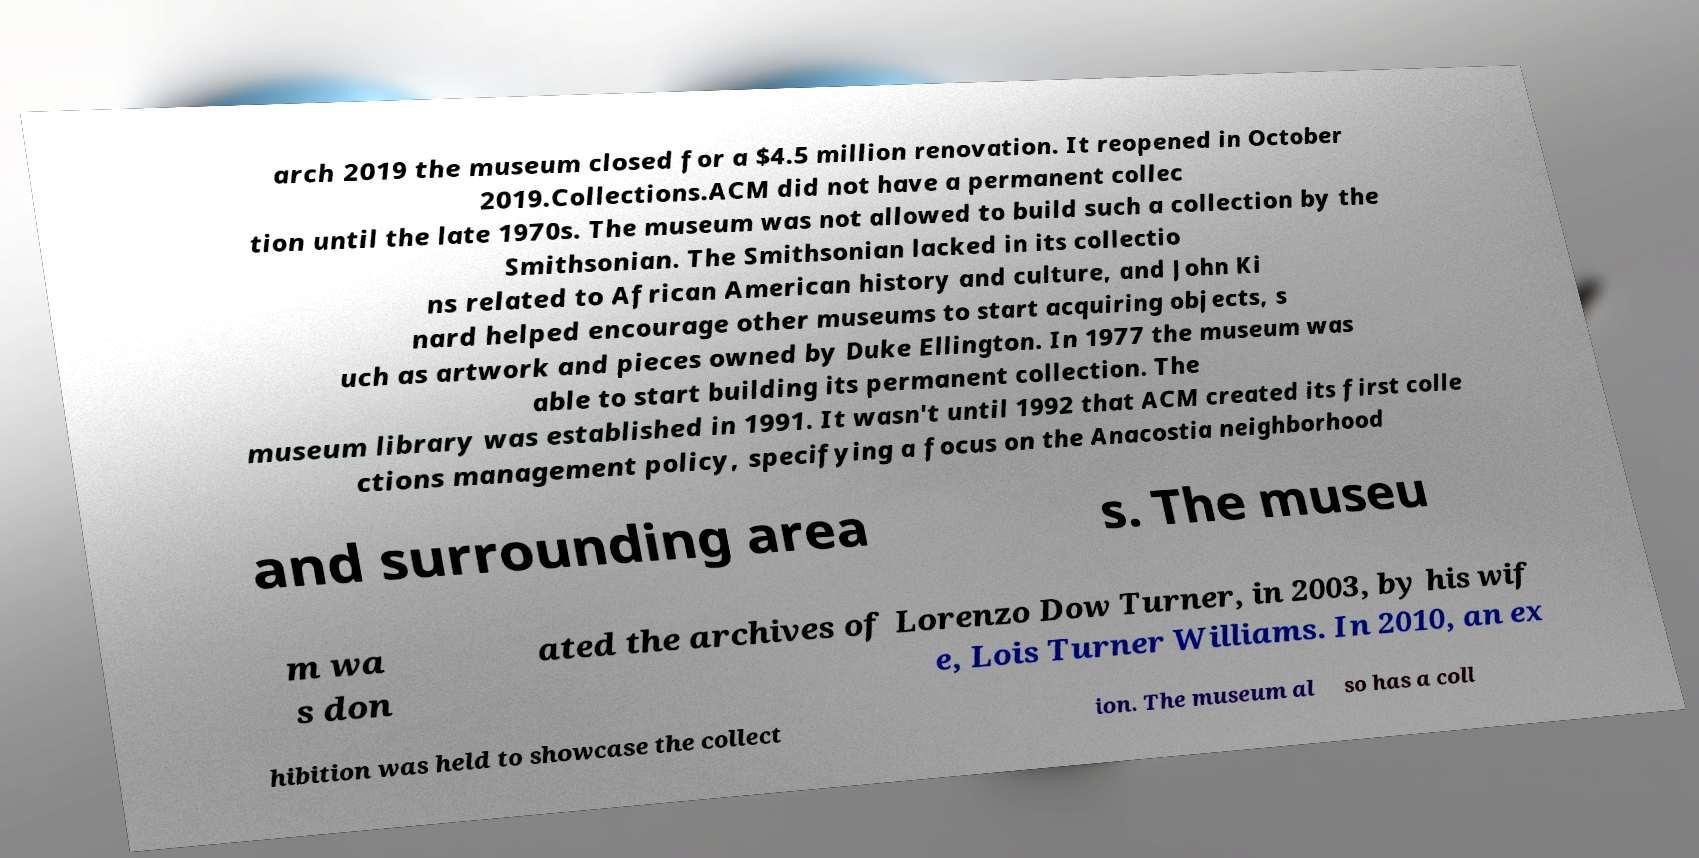There's text embedded in this image that I need extracted. Can you transcribe it verbatim? arch 2019 the museum closed for a $4.5 million renovation. It reopened in October 2019.Collections.ACM did not have a permanent collec tion until the late 1970s. The museum was not allowed to build such a collection by the Smithsonian. The Smithsonian lacked in its collectio ns related to African American history and culture, and John Ki nard helped encourage other museums to start acquiring objects, s uch as artwork and pieces owned by Duke Ellington. In 1977 the museum was able to start building its permanent collection. The museum library was established in 1991. It wasn't until 1992 that ACM created its first colle ctions management policy, specifying a focus on the Anacostia neighborhood and surrounding area s. The museu m wa s don ated the archives of Lorenzo Dow Turner, in 2003, by his wif e, Lois Turner Williams. In 2010, an ex hibition was held to showcase the collect ion. The museum al so has a coll 